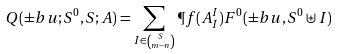Convert formula to latex. <formula><loc_0><loc_0><loc_500><loc_500>Q ( \pm b { u } ; S ^ { 0 } , S ; A ) = \sum _ { I \in \binom { S } { m - n } } \P f ( A _ { I } ^ { I } ) F ^ { 0 } ( \pm b { u } , S ^ { 0 } \uplus I )</formula> 